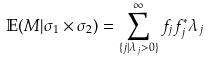Convert formula to latex. <formula><loc_0><loc_0><loc_500><loc_500>\mathbb { E } ( M | \sigma _ { 1 } \times \sigma _ { 2 } ) = \sum _ { \{ j | \lambda _ { j } > 0 \} } ^ { \infty } f _ { j } f _ { j } ^ { * } \lambda _ { j }</formula> 